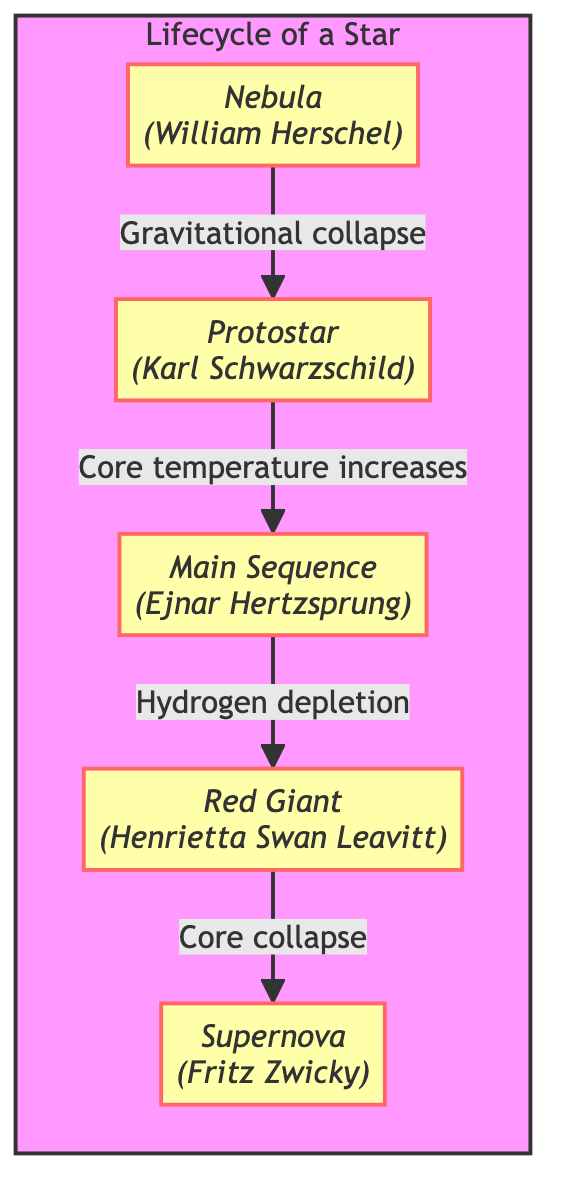What is the first stage in the lifecycle of a star? The diagram indicates that the first stage is the "Nebula," as it is the starting point of the flowchart.
Answer: Nebula Who contributed to the knowledge of the protostar stage? The diagram attributes the discovery related to the protostar stage to Karl Schwarzschild.
Answer: Karl Schwarzschild How does a protostar evolve into the main sequence? The relationship shown in the diagram indicates that a protostar evolves into a main sequence star through the increase of core temperature.
Answer: Core temperature increases What causes a star to enter the red giant phase? According to the diagram, the transition to the red giant phase occurs after "Hydrogen depletion" in the main sequence phase.
Answer: Hydrogen depletion Which stage is associated with Fritz Zwicky? The diagram assigns Fritz Zwicky to the "Supernova" stage, making it clear who contributed to this aspect.
Answer: Supernova What is the final stage a star reaches in this lifecycle? By following the flow of the diagram, it shows that the final stage a star reaches is a supernova.
Answer: Supernova How many stages are depicted in the lifecycle of a star? The diagram displays five stages, as evidenced by the number of nodes connected in succession.
Answer: Five What occurs during the transition from the red giant to supernova stage? The diagram indicates that a "Core collapse" occurs during this transition, marking a significant change in the lifecycle.
Answer: Core collapse Which notable figure is linked to the red giant stage? The diagram clearly states that Henrietta Swan Leavitt is associated with the red giant stage in the lifecycle.
Answer: Henrietta Swan Leavitt What does the arrow between nebula and protostar indicate? The arrow signifies a "Gravitational collapse," indicating the process that leads from one stage to the next in the star's lifecycle.
Answer: Gravitational collapse 